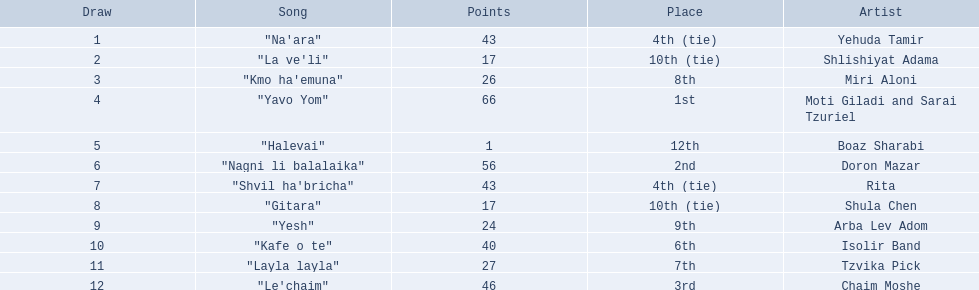What is the place of the contestant who received only 1 point? 12th. What is the name of the artist listed in the previous question? Boaz Sharabi. 